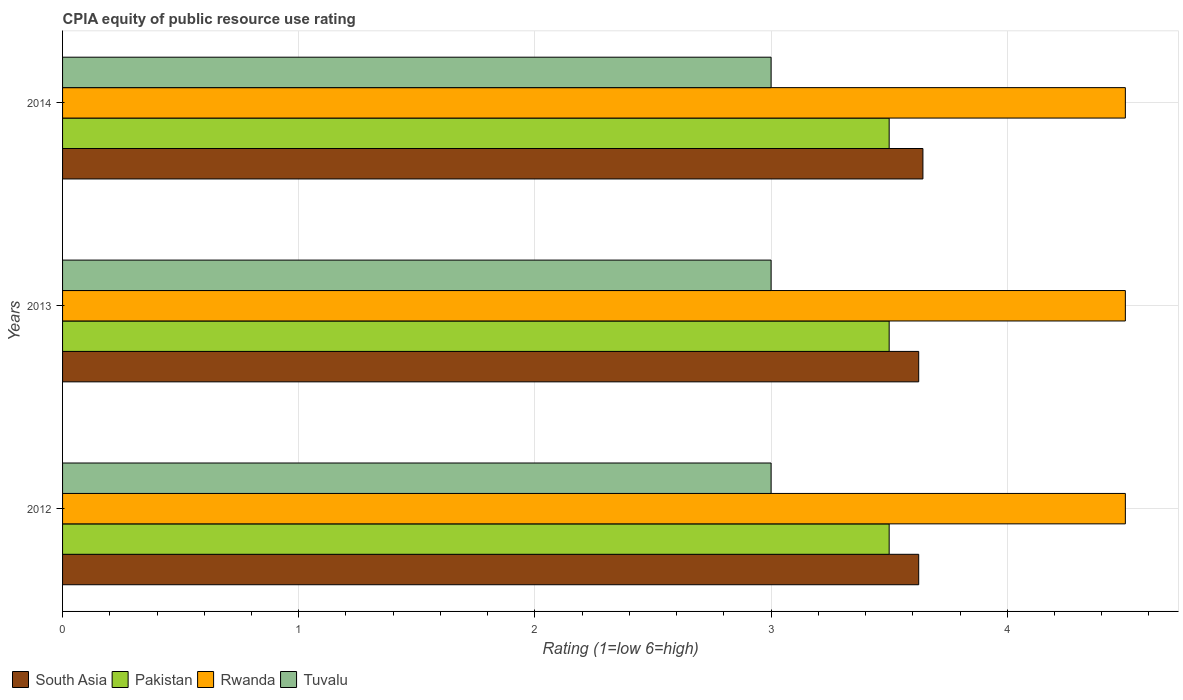How many groups of bars are there?
Provide a short and direct response. 3. Are the number of bars on each tick of the Y-axis equal?
Provide a short and direct response. Yes. How many bars are there on the 1st tick from the top?
Offer a terse response. 4. Across all years, what is the maximum CPIA rating in Pakistan?
Your response must be concise. 3.5. In which year was the CPIA rating in South Asia maximum?
Your answer should be compact. 2014. In which year was the CPIA rating in Pakistan minimum?
Your answer should be compact. 2012. What is the total CPIA rating in Tuvalu in the graph?
Your answer should be very brief. 9. What is the difference between the CPIA rating in Tuvalu in 2012 and that in 2013?
Provide a succinct answer. 0. What is the difference between the CPIA rating in Rwanda in 2014 and the CPIA rating in Pakistan in 2012?
Keep it short and to the point. 1. What is the ratio of the CPIA rating in Pakistan in 2012 to that in 2014?
Give a very brief answer. 1. Is the difference between the CPIA rating in Tuvalu in 2012 and 2014 greater than the difference between the CPIA rating in Rwanda in 2012 and 2014?
Ensure brevity in your answer.  No. What is the difference between the highest and the second highest CPIA rating in South Asia?
Your answer should be compact. 0.02. Is the sum of the CPIA rating in Pakistan in 2012 and 2014 greater than the maximum CPIA rating in South Asia across all years?
Give a very brief answer. Yes. Is it the case that in every year, the sum of the CPIA rating in Pakistan and CPIA rating in South Asia is greater than the sum of CPIA rating in Rwanda and CPIA rating in Tuvalu?
Make the answer very short. No. What does the 1st bar from the top in 2012 represents?
Keep it short and to the point. Tuvalu. Is it the case that in every year, the sum of the CPIA rating in Rwanda and CPIA rating in Pakistan is greater than the CPIA rating in South Asia?
Give a very brief answer. Yes. How many bars are there?
Your answer should be very brief. 12. What is the title of the graph?
Your response must be concise. CPIA equity of public resource use rating. What is the label or title of the Y-axis?
Provide a succinct answer. Years. What is the Rating (1=low 6=high) in South Asia in 2012?
Your answer should be very brief. 3.62. What is the Rating (1=low 6=high) in Rwanda in 2012?
Offer a very short reply. 4.5. What is the Rating (1=low 6=high) in Tuvalu in 2012?
Your answer should be compact. 3. What is the Rating (1=low 6=high) of South Asia in 2013?
Your response must be concise. 3.62. What is the Rating (1=low 6=high) of Tuvalu in 2013?
Your answer should be compact. 3. What is the Rating (1=low 6=high) in South Asia in 2014?
Your answer should be very brief. 3.64. What is the Rating (1=low 6=high) of Tuvalu in 2014?
Your answer should be compact. 3. Across all years, what is the maximum Rating (1=low 6=high) in South Asia?
Provide a succinct answer. 3.64. Across all years, what is the maximum Rating (1=low 6=high) in Tuvalu?
Provide a succinct answer. 3. Across all years, what is the minimum Rating (1=low 6=high) in South Asia?
Give a very brief answer. 3.62. Across all years, what is the minimum Rating (1=low 6=high) in Pakistan?
Give a very brief answer. 3.5. Across all years, what is the minimum Rating (1=low 6=high) of Tuvalu?
Provide a short and direct response. 3. What is the total Rating (1=low 6=high) of South Asia in the graph?
Give a very brief answer. 10.89. What is the difference between the Rating (1=low 6=high) of South Asia in 2012 and that in 2013?
Your answer should be very brief. 0. What is the difference between the Rating (1=low 6=high) of South Asia in 2012 and that in 2014?
Make the answer very short. -0.02. What is the difference between the Rating (1=low 6=high) in Rwanda in 2012 and that in 2014?
Keep it short and to the point. 0. What is the difference between the Rating (1=low 6=high) in South Asia in 2013 and that in 2014?
Offer a very short reply. -0.02. What is the difference between the Rating (1=low 6=high) in Pakistan in 2013 and that in 2014?
Keep it short and to the point. 0. What is the difference between the Rating (1=low 6=high) in Rwanda in 2013 and that in 2014?
Your response must be concise. 0. What is the difference between the Rating (1=low 6=high) in Tuvalu in 2013 and that in 2014?
Offer a terse response. 0. What is the difference between the Rating (1=low 6=high) in South Asia in 2012 and the Rating (1=low 6=high) in Rwanda in 2013?
Give a very brief answer. -0.88. What is the difference between the Rating (1=low 6=high) of South Asia in 2012 and the Rating (1=low 6=high) of Tuvalu in 2013?
Provide a short and direct response. 0.62. What is the difference between the Rating (1=low 6=high) in Pakistan in 2012 and the Rating (1=low 6=high) in Rwanda in 2013?
Offer a terse response. -1. What is the difference between the Rating (1=low 6=high) of Rwanda in 2012 and the Rating (1=low 6=high) of Tuvalu in 2013?
Give a very brief answer. 1.5. What is the difference between the Rating (1=low 6=high) in South Asia in 2012 and the Rating (1=low 6=high) in Rwanda in 2014?
Give a very brief answer. -0.88. What is the difference between the Rating (1=low 6=high) of South Asia in 2012 and the Rating (1=low 6=high) of Tuvalu in 2014?
Provide a succinct answer. 0.62. What is the difference between the Rating (1=low 6=high) of Pakistan in 2012 and the Rating (1=low 6=high) of Tuvalu in 2014?
Ensure brevity in your answer.  0.5. What is the difference between the Rating (1=low 6=high) of Rwanda in 2012 and the Rating (1=low 6=high) of Tuvalu in 2014?
Your answer should be very brief. 1.5. What is the difference between the Rating (1=low 6=high) of South Asia in 2013 and the Rating (1=low 6=high) of Rwanda in 2014?
Your answer should be very brief. -0.88. What is the difference between the Rating (1=low 6=high) in Pakistan in 2013 and the Rating (1=low 6=high) in Tuvalu in 2014?
Offer a very short reply. 0.5. What is the average Rating (1=low 6=high) of South Asia per year?
Keep it short and to the point. 3.63. In the year 2012, what is the difference between the Rating (1=low 6=high) of South Asia and Rating (1=low 6=high) of Pakistan?
Your answer should be compact. 0.12. In the year 2012, what is the difference between the Rating (1=low 6=high) in South Asia and Rating (1=low 6=high) in Rwanda?
Provide a short and direct response. -0.88. In the year 2012, what is the difference between the Rating (1=low 6=high) in Pakistan and Rating (1=low 6=high) in Rwanda?
Your answer should be compact. -1. In the year 2012, what is the difference between the Rating (1=low 6=high) of Rwanda and Rating (1=low 6=high) of Tuvalu?
Make the answer very short. 1.5. In the year 2013, what is the difference between the Rating (1=low 6=high) in South Asia and Rating (1=low 6=high) in Rwanda?
Offer a terse response. -0.88. In the year 2013, what is the difference between the Rating (1=low 6=high) of South Asia and Rating (1=low 6=high) of Tuvalu?
Offer a terse response. 0.62. In the year 2013, what is the difference between the Rating (1=low 6=high) in Pakistan and Rating (1=low 6=high) in Rwanda?
Your answer should be very brief. -1. In the year 2013, what is the difference between the Rating (1=low 6=high) in Pakistan and Rating (1=low 6=high) in Tuvalu?
Keep it short and to the point. 0.5. In the year 2013, what is the difference between the Rating (1=low 6=high) in Rwanda and Rating (1=low 6=high) in Tuvalu?
Your response must be concise. 1.5. In the year 2014, what is the difference between the Rating (1=low 6=high) of South Asia and Rating (1=low 6=high) of Pakistan?
Keep it short and to the point. 0.14. In the year 2014, what is the difference between the Rating (1=low 6=high) of South Asia and Rating (1=low 6=high) of Rwanda?
Your answer should be compact. -0.86. In the year 2014, what is the difference between the Rating (1=low 6=high) of South Asia and Rating (1=low 6=high) of Tuvalu?
Your answer should be compact. 0.64. In the year 2014, what is the difference between the Rating (1=low 6=high) of Pakistan and Rating (1=low 6=high) of Rwanda?
Your answer should be compact. -1. In the year 2014, what is the difference between the Rating (1=low 6=high) of Pakistan and Rating (1=low 6=high) of Tuvalu?
Your answer should be compact. 0.5. What is the ratio of the Rating (1=low 6=high) in Rwanda in 2012 to that in 2013?
Your answer should be very brief. 1. What is the ratio of the Rating (1=low 6=high) of Tuvalu in 2012 to that in 2013?
Provide a succinct answer. 1. What is the ratio of the Rating (1=low 6=high) in Tuvalu in 2012 to that in 2014?
Give a very brief answer. 1. What is the ratio of the Rating (1=low 6=high) in South Asia in 2013 to that in 2014?
Make the answer very short. 1. What is the ratio of the Rating (1=low 6=high) in Pakistan in 2013 to that in 2014?
Keep it short and to the point. 1. What is the ratio of the Rating (1=low 6=high) of Rwanda in 2013 to that in 2014?
Ensure brevity in your answer.  1. What is the difference between the highest and the second highest Rating (1=low 6=high) of South Asia?
Offer a terse response. 0.02. What is the difference between the highest and the second highest Rating (1=low 6=high) of Pakistan?
Offer a very short reply. 0. What is the difference between the highest and the second highest Rating (1=low 6=high) in Rwanda?
Your answer should be compact. 0. What is the difference between the highest and the second highest Rating (1=low 6=high) of Tuvalu?
Your answer should be very brief. 0. What is the difference between the highest and the lowest Rating (1=low 6=high) of South Asia?
Your response must be concise. 0.02. What is the difference between the highest and the lowest Rating (1=low 6=high) of Pakistan?
Your answer should be compact. 0. What is the difference between the highest and the lowest Rating (1=low 6=high) in Rwanda?
Your response must be concise. 0. What is the difference between the highest and the lowest Rating (1=low 6=high) in Tuvalu?
Give a very brief answer. 0. 